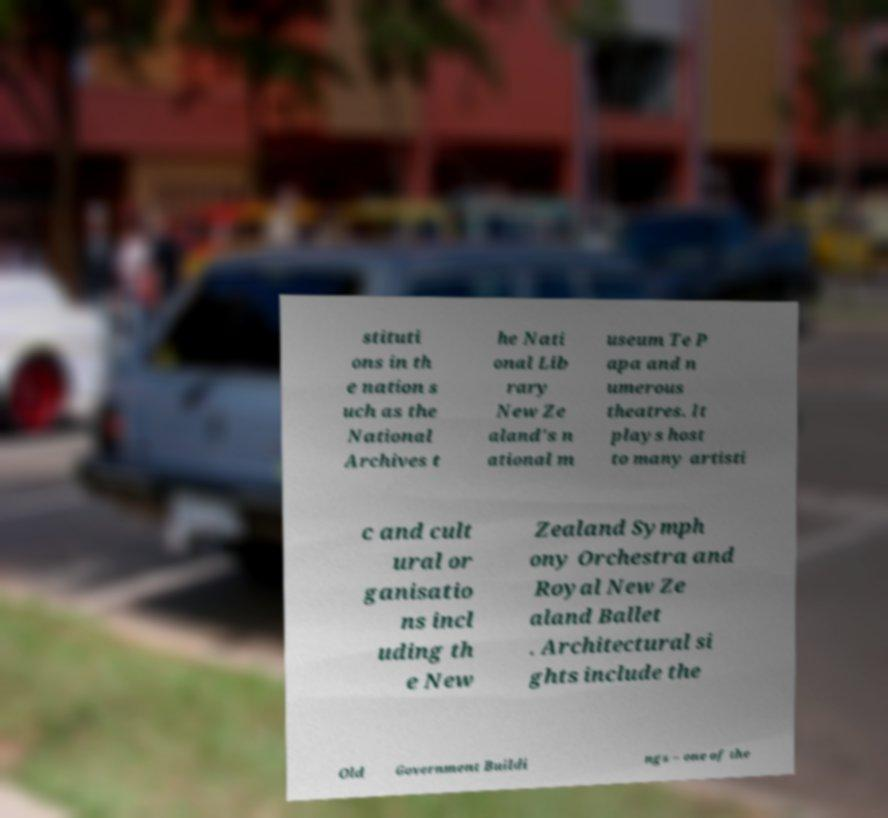There's text embedded in this image that I need extracted. Can you transcribe it verbatim? stituti ons in th e nation s uch as the National Archives t he Nati onal Lib rary New Ze aland's n ational m useum Te P apa and n umerous theatres. It plays host to many artisti c and cult ural or ganisatio ns incl uding th e New Zealand Symph ony Orchestra and Royal New Ze aland Ballet . Architectural si ghts include the Old Government Buildi ngs – one of the 